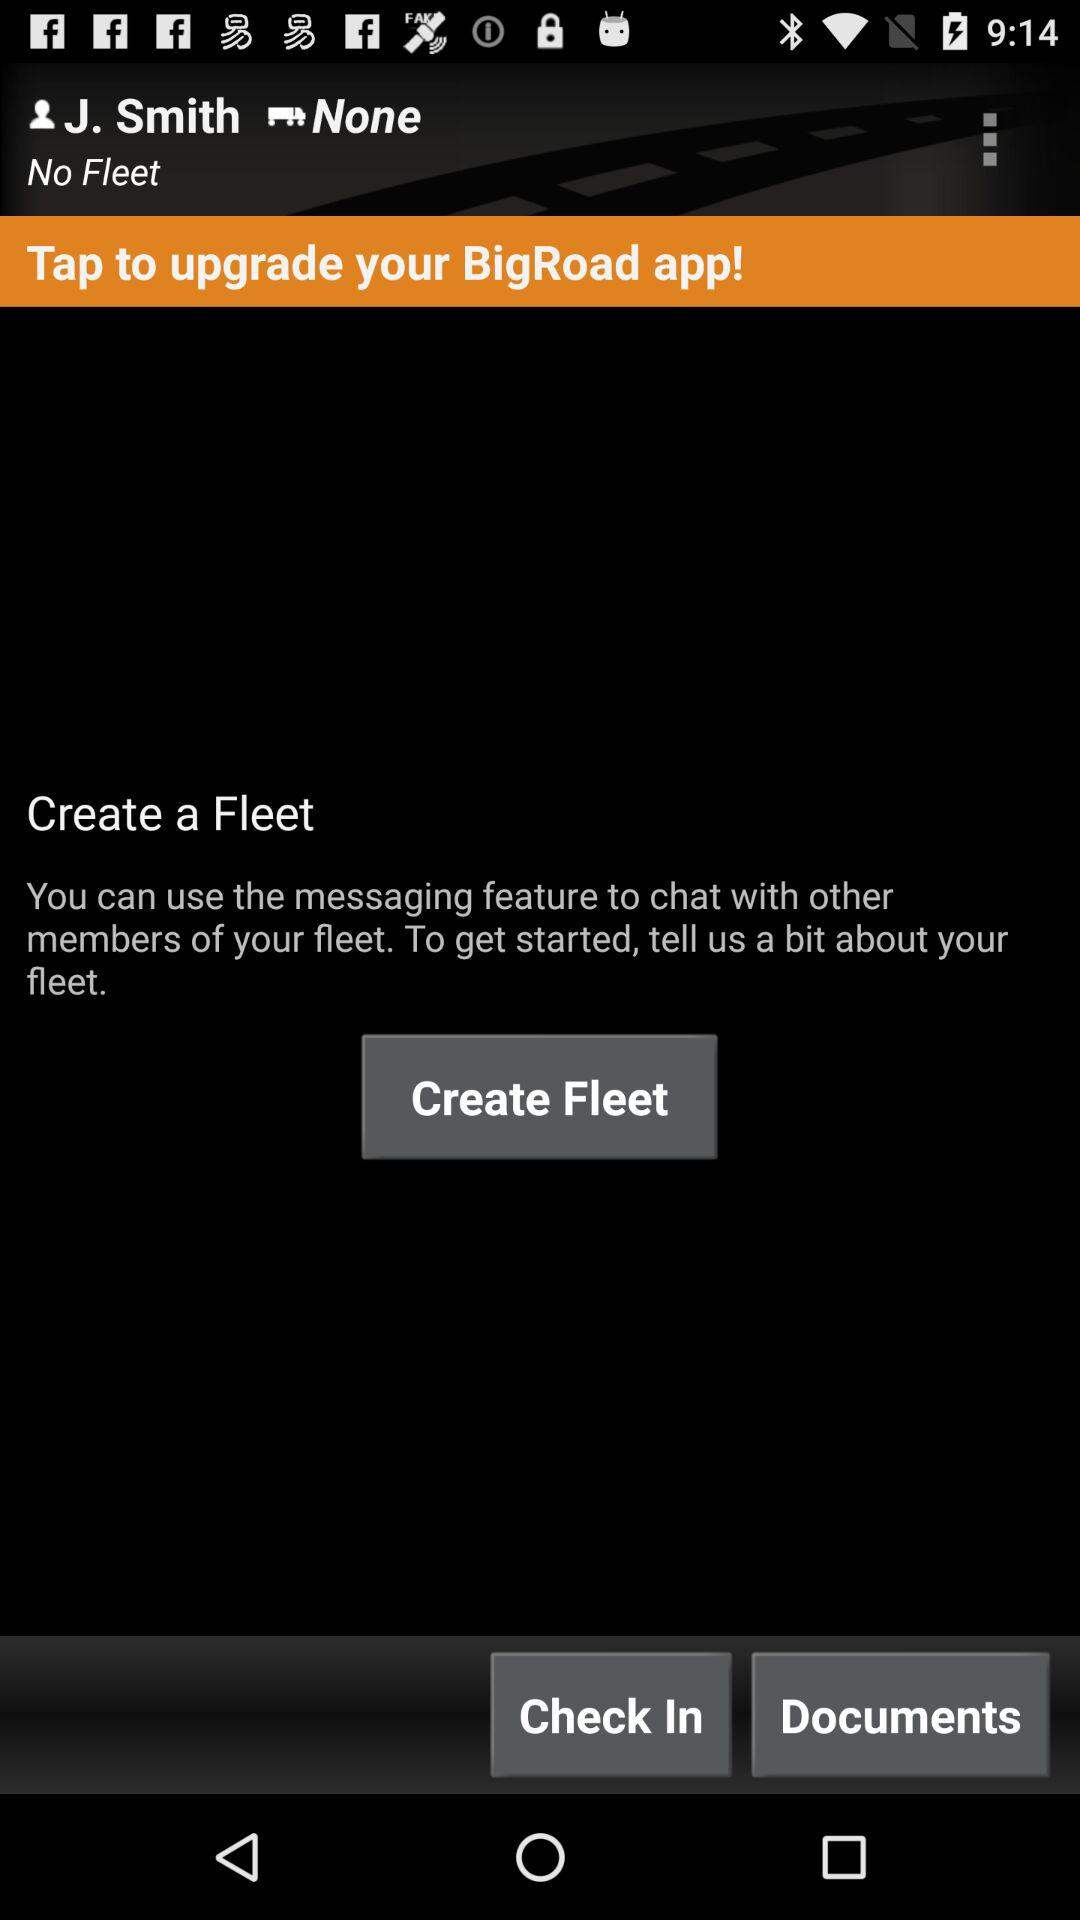What is the name of the application? The name of the application is "BigRoad". 